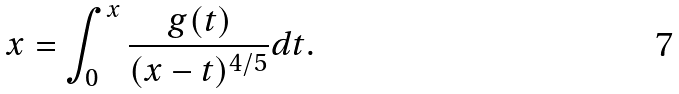<formula> <loc_0><loc_0><loc_500><loc_500>x = \int _ { 0 } ^ { x } \frac { g ( t ) } { ( x - t ) ^ { 4 / 5 } } d t .</formula> 